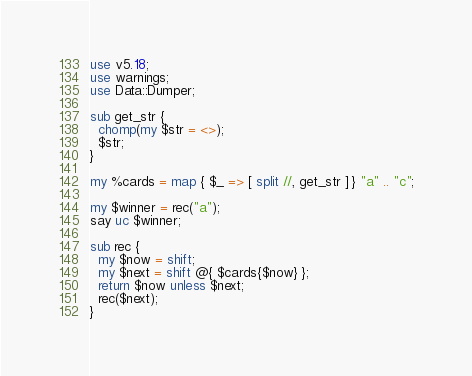Convert code to text. <code><loc_0><loc_0><loc_500><loc_500><_Perl_>use v5.18;
use warnings;
use Data::Dumper;

sub get_str {
  chomp(my $str = <>);
  $str;
}

my %cards = map { $_ => [ split //, get_str ] } "a" .. "c";

my $winner = rec("a");
say uc $winner;

sub rec {
  my $now = shift;
  my $next = shift @{ $cards{$now} };
  return $now unless $next;
  rec($next);
}
</code> 